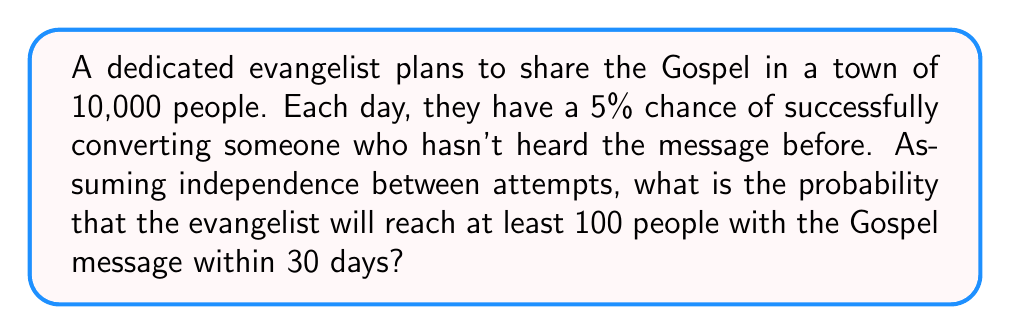Could you help me with this problem? Let's approach this step-by-step:

1) First, we need to model this situation. This follows a binomial distribution, where each day is a trial, and success is defined as reaching a new person.

2) The probability of success on any given day is $p = 0.05$

3) The number of trials (days) is $n = 30$

4) We want to find the probability of reaching at least 100 people, which means we need to calculate $P(X \geq 100)$, where $X$ is the number of people reached.

5) It's easier to calculate $P(X < 100)$ and then subtract from 1:

   $P(X \geq 100) = 1 - P(X < 100) = 1 - P(X \leq 99)$

6) The probability mass function for a binomial distribution is:

   $P(X = k) = \binom{n}{k} p^k (1-p)^{n-k}$

7) We need to sum this for all $k$ from 0 to 99:

   $P(X \leq 99) = \sum_{k=0}^{99} \binom{30}{k} (0.05)^k (0.95)^{30-k}$

8) This sum is computationally intensive, so we'll use the cumulative distribution function of the binomial distribution, which can be approximated using the normal distribution when $np$ and $n(1-p)$ are both greater than 5 (which they are in this case).

9) The normal approximation uses $\mu = np$ and $\sigma = \sqrt{np(1-p)}$:

   $\mu = 30 * 0.05 = 1.5$
   $\sigma = \sqrt{30 * 0.05 * 0.95} \approx 1.19$

10) We then calculate the z-score for 99.5 (using continuity correction):

    $z = \frac{99.5 - 1.5}{1.19} \approx 82.35$

11) The probability $P(X < 100)$ is equivalent to $\Phi(82.35)$, where $\Phi$ is the standard normal cumulative distribution function.

12) $\Phi(82.35)$ is essentially 1 for all practical purposes.

13) Therefore, $P(X \geq 100) = 1 - \Phi(82.35) \approx 0$
Answer: $\approx 0$ 